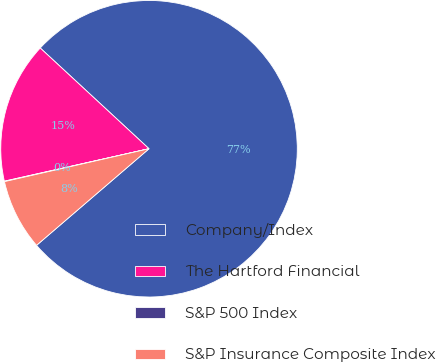Convert chart. <chart><loc_0><loc_0><loc_500><loc_500><pie_chart><fcel>Company/Index<fcel>The Hartford Financial<fcel>S&P 500 Index<fcel>S&P Insurance Composite Index<nl><fcel>76.81%<fcel>15.4%<fcel>0.05%<fcel>7.73%<nl></chart> 